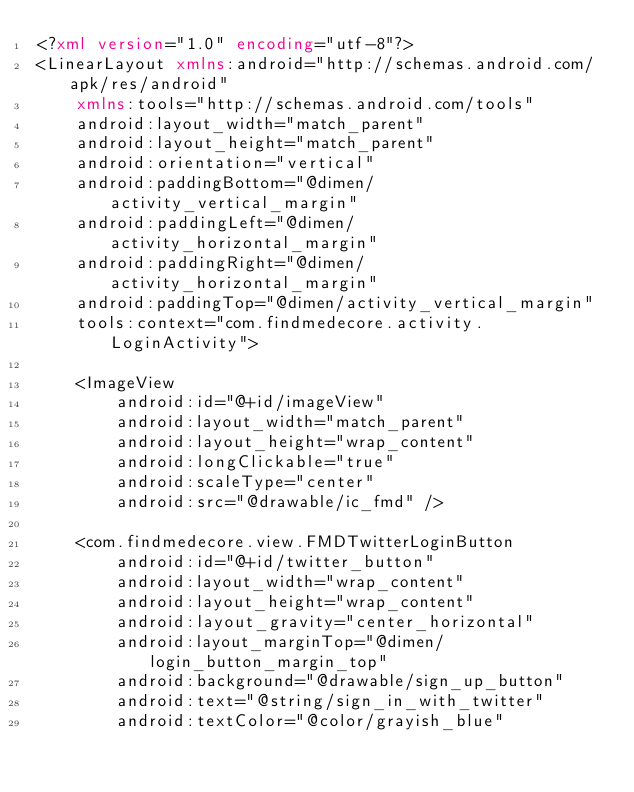Convert code to text. <code><loc_0><loc_0><loc_500><loc_500><_XML_><?xml version="1.0" encoding="utf-8"?>
<LinearLayout xmlns:android="http://schemas.android.com/apk/res/android"
    xmlns:tools="http://schemas.android.com/tools"
    android:layout_width="match_parent"
    android:layout_height="match_parent"
    android:orientation="vertical"
    android:paddingBottom="@dimen/activity_vertical_margin"
    android:paddingLeft="@dimen/activity_horizontal_margin"
    android:paddingRight="@dimen/activity_horizontal_margin"
    android:paddingTop="@dimen/activity_vertical_margin"
    tools:context="com.findmedecore.activity.LoginActivity">

    <ImageView
        android:id="@+id/imageView"
        android:layout_width="match_parent"
        android:layout_height="wrap_content"
        android:longClickable="true"
        android:scaleType="center"
        android:src="@drawable/ic_fmd" />

    <com.findmedecore.view.FMDTwitterLoginButton
        android:id="@+id/twitter_button"
        android:layout_width="wrap_content"
        android:layout_height="wrap_content"
        android:layout_gravity="center_horizontal"
        android:layout_marginTop="@dimen/login_button_margin_top"
        android:background="@drawable/sign_up_button"
        android:text="@string/sign_in_with_twitter"
        android:textColor="@color/grayish_blue"</code> 